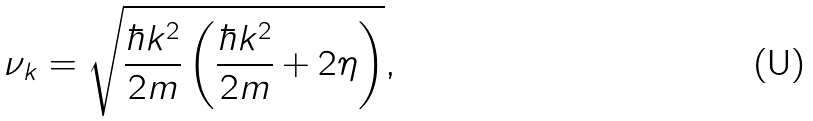<formula> <loc_0><loc_0><loc_500><loc_500>\nu _ { k } = \sqrt { \frac { \hbar { k } ^ { 2 } } { 2 m } \left ( \frac { \hbar { k } ^ { 2 } } { 2 m } + 2 \eta \right ) } ,</formula> 